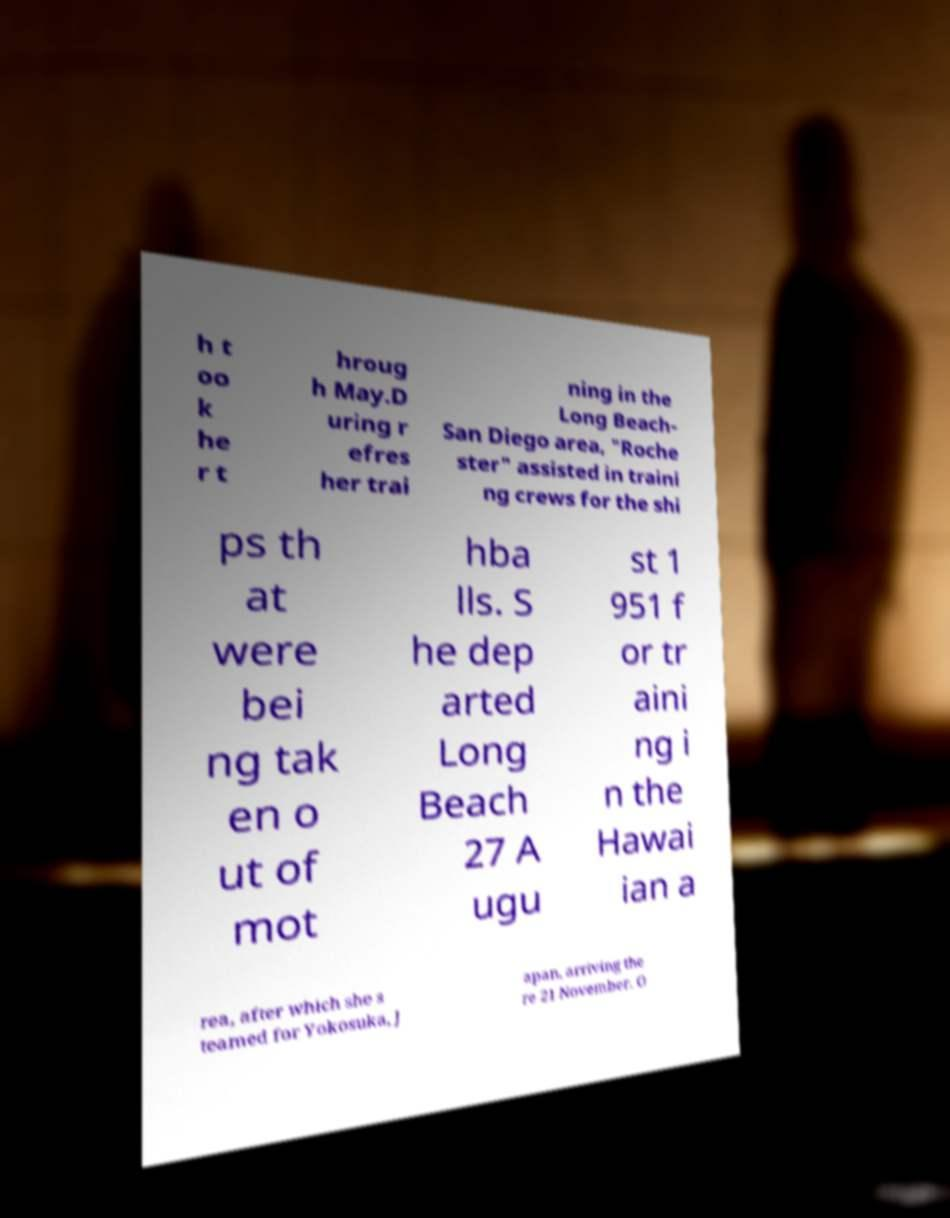Please identify and transcribe the text found in this image. h t oo k he r t hroug h May.D uring r efres her trai ning in the Long Beach- San Diego area, "Roche ster" assisted in traini ng crews for the shi ps th at were bei ng tak en o ut of mot hba lls. S he dep arted Long Beach 27 A ugu st 1 951 f or tr aini ng i n the Hawai ian a rea, after which she s teamed for Yokosuka, J apan, arriving the re 21 November. O 